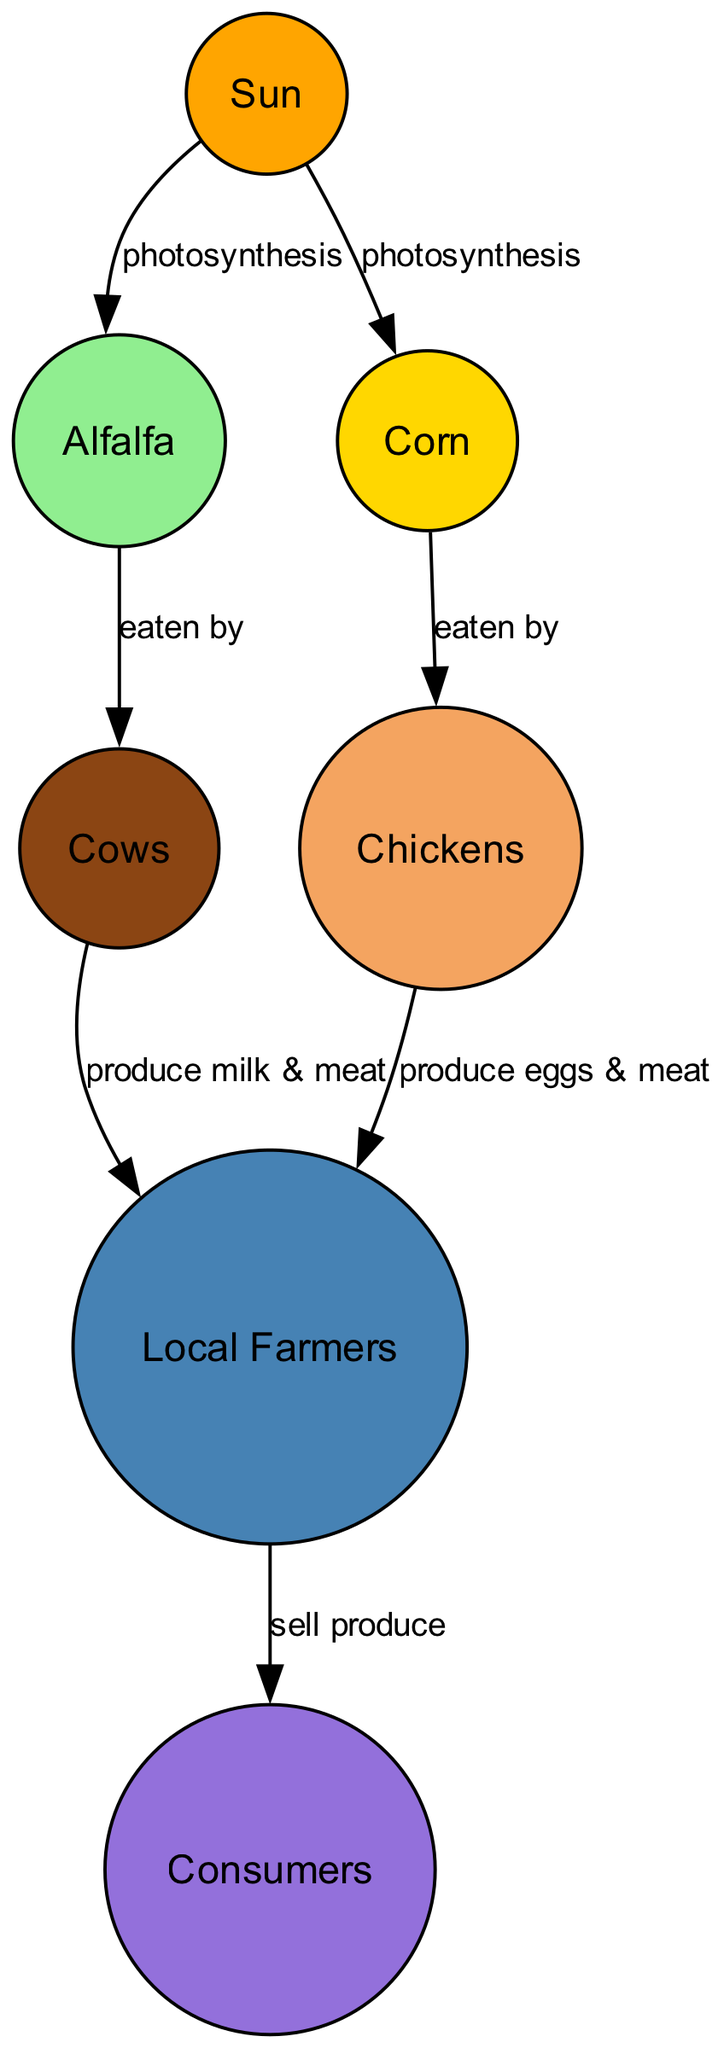What is the primary source of energy for the food web? The diagram shows that the Sun is the primary source of energy. All energy in this food web starts with the Sun, which drives the process of photosynthesis in plants.
Answer: Sun How many producers are identified in the food web? The diagram highlights two producers: alfalfa and corn. These are the plants that use sunlight to create energy through photosynthesis.
Answer: 2 What do cows produce for farmers? According to the diagram, cows produce milk and meat for farmers. This relationship is directly shown as an edge stemming from cows to farmers.
Answer: milk & meat Which animal in the food web is eaten by chickens? The diagram indicates that chickens eat corn. The edge labeled "eaten by" connects corn to chickens, establishing this relationship.
Answer: corn Who sells the produce to consumers? The diagram clearly shows that local farmers sell the produce to consumers. This is depicted by the edge from farmers to consumers labeled "sell produce."
Answer: Local Farmers What role does alfalfa play in the food web? Alfalfa is a producer in the food web that acts as a food source for cows. This relationship is illustrated with the label "eaten by" connecting alfalfa to cows.
Answer: producer Which component of the food web produces eggs? The diagram specifies that chickens produce eggs for farmers. It shows a clear connection from chickens to farmers labeled "produce eggs & meat."
Answer: chickens What type of relationship exists between cows and local farmers? The diagram illustrates that cows provide milk and meat to farmers; this is a producer-consumer relationship where cows are a source of products for farmers.
Answer: produce milk & meat How does the energy from the Sun initially start the food web? The Sun provides energy through photosynthesis, which is the process that enables plants like alfalfa and corn to convert sunlight into usable energy, starting the food chain.
Answer: photosynthesis 